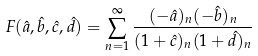Convert formula to latex. <formula><loc_0><loc_0><loc_500><loc_500>F ( \hat { a } , \hat { b } , \hat { c } , \hat { d } ) = \sum _ { n = 1 } ^ { \infty } \frac { ( - \hat { a } ) _ { n } ( - \hat { b } ) _ { n } } { ( 1 + \hat { c } ) _ { n } ( 1 + \hat { d } ) _ { n } }</formula> 